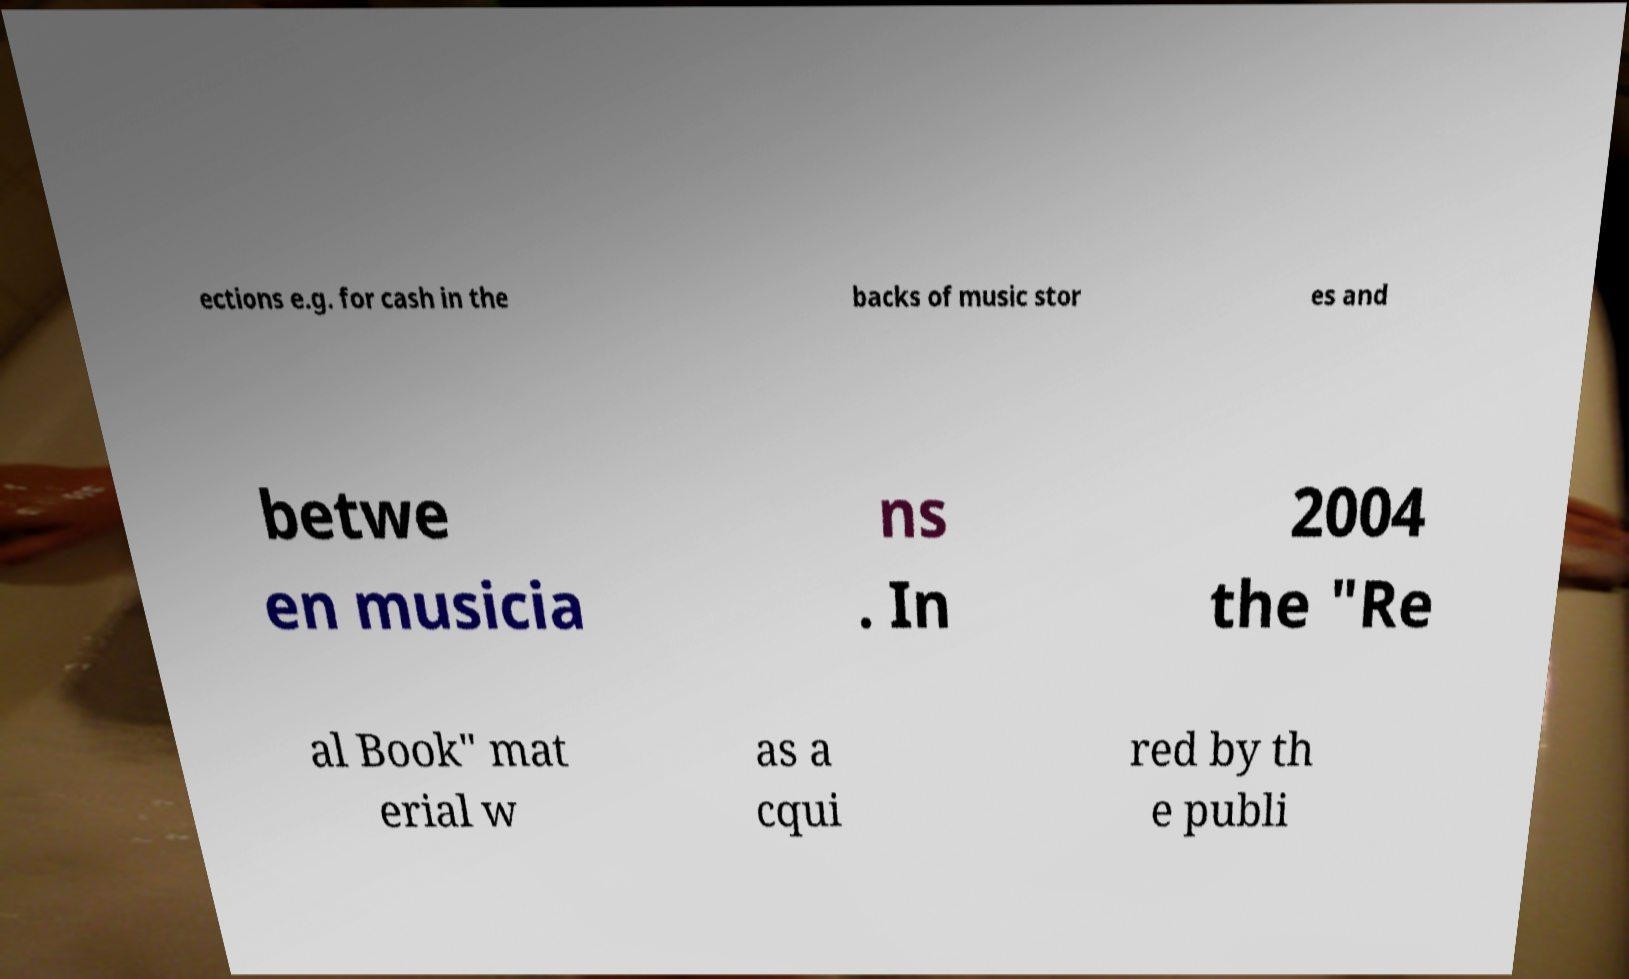What messages or text are displayed in this image? I need them in a readable, typed format. ections e.g. for cash in the backs of music stor es and betwe en musicia ns . In 2004 the "Re al Book" mat erial w as a cqui red by th e publi 